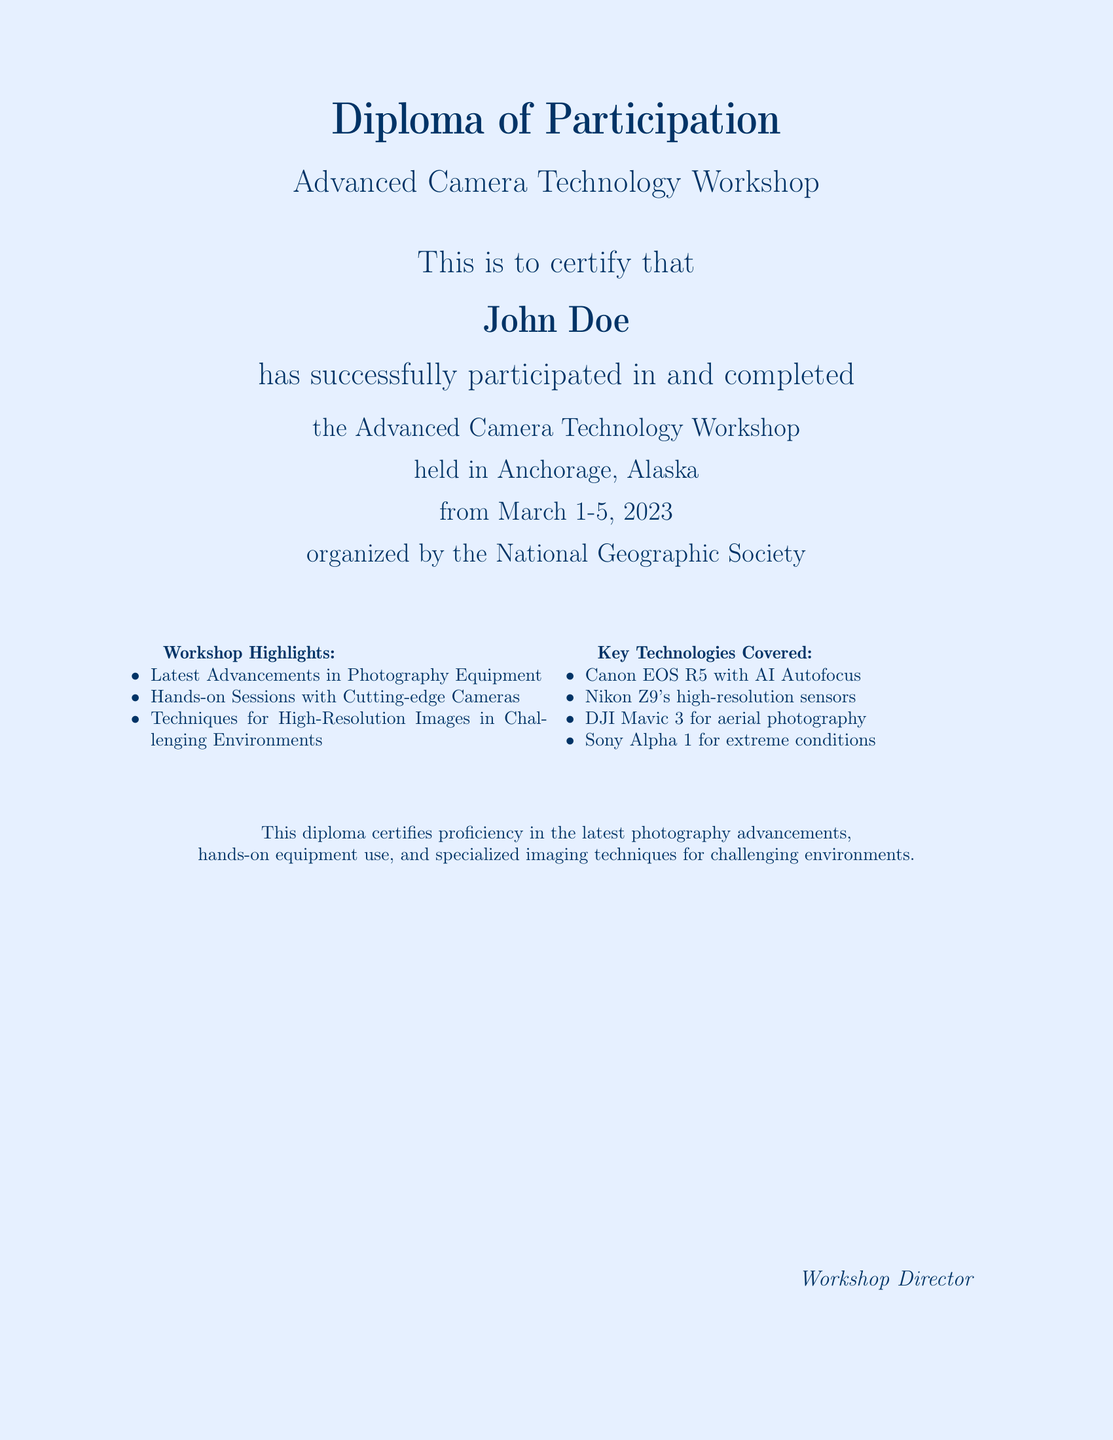What is the title of the workshop? The title of the workshop is given in the document as "Advanced Camera Technology Workshop."
Answer: Advanced Camera Technology Workshop Who is the participant named in the diploma? The participant's name is explicitly stated in the diploma section as "John Doe."
Answer: John Doe Where was the workshop held? The document specifies the location of the workshop as "Anchorage, Alaska."
Answer: Anchorage, Alaska What were the dates of the workshop? The dates for the workshop are mentioned as "March 1-5, 2023."
Answer: March 1-5, 2023 Which organization organized the workshop? The document names "National Geographic Society" as the organizing body of the workshop.
Answer: National Geographic Society What advanced camera model features AI Autofocus? The document lists "Canon EOS R5" as the model that includes AI Autofocus technology.
Answer: Canon EOS R5 Which technology is noted for aerial photography? The document identifies "DJI Mavic 3" as the technology specifically for aerial photography.
Answer: DJI Mavic 3 What kind of techniques were taught at the workshop? The techniques learned focus on capturing "high-resolution images in challenging environments."
Answer: high-resolution images in challenging environments Who signed off as the workshop director? The document includes a section for the "Workshop Director," indicating that they signed.
Answer: Workshop Director 